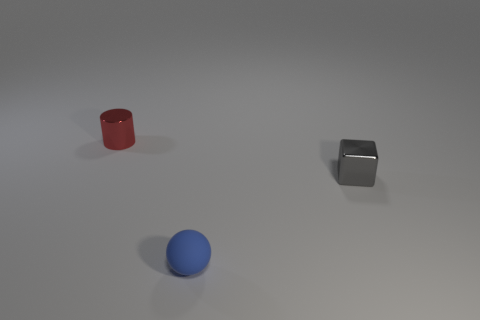Can you tell me the colors of the objects in the image? Certainly! The image displays three objects, each with a distinct color: there's a red cylindrical object, a gray cube, and a blue sphere. 